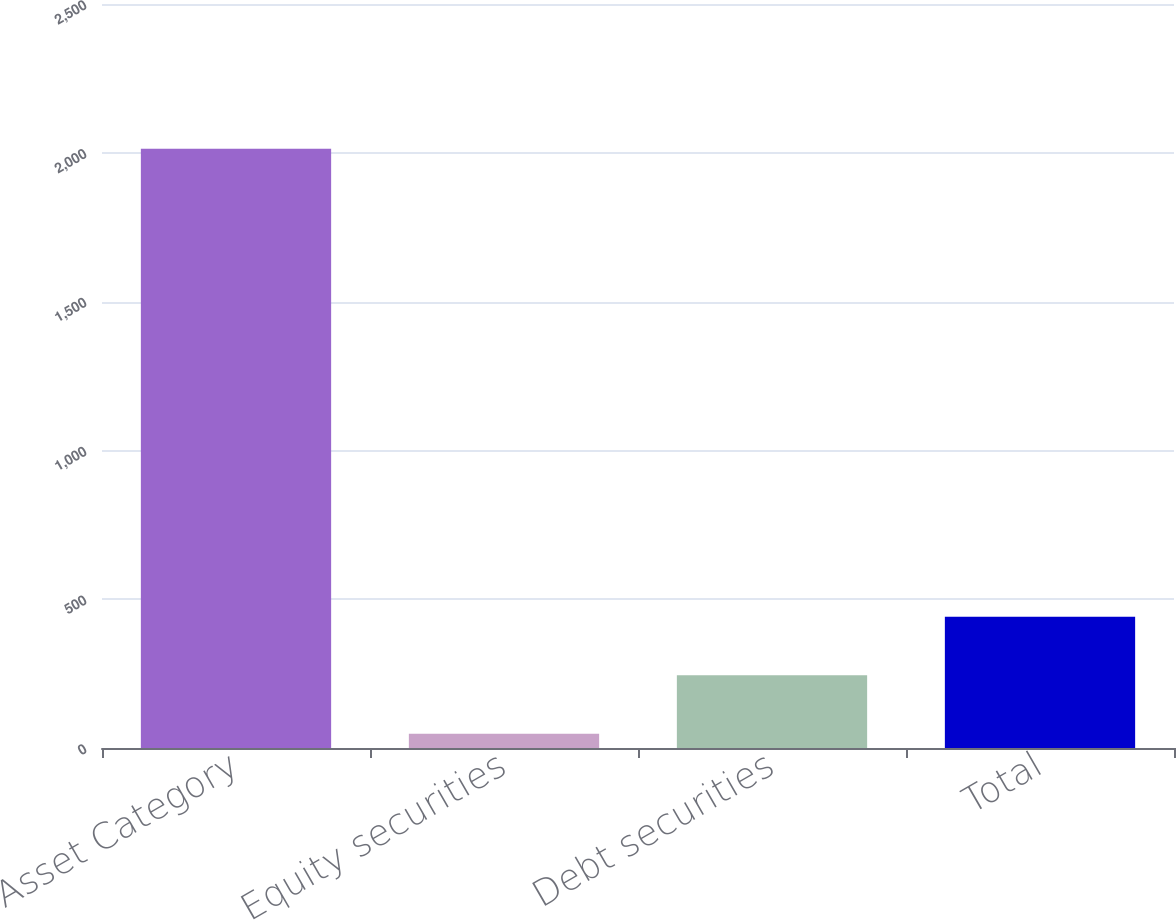Convert chart to OTSL. <chart><loc_0><loc_0><loc_500><loc_500><bar_chart><fcel>Asset Category<fcel>Equity securities<fcel>Debt securities<fcel>Total<nl><fcel>2014<fcel>48<fcel>244.6<fcel>441.2<nl></chart> 